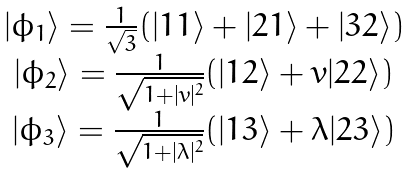Convert formula to latex. <formula><loc_0><loc_0><loc_500><loc_500>\begin{array} { c c c c c c } | \phi _ { 1 } \rangle = \frac { 1 } { \sqrt { 3 } } ( | 1 1 \rangle + | 2 1 \rangle + | 3 2 \rangle ) \\ | \phi _ { 2 } \rangle = \frac { 1 } { \sqrt { 1 + | v | ^ { 2 } } } ( | 1 2 \rangle + v | 2 2 \rangle ) \\ | \phi _ { 3 } \rangle = \frac { 1 } { \sqrt { 1 + | \lambda | ^ { 2 } } } ( | 1 3 \rangle + \lambda | 2 3 \rangle ) \\ \end{array}</formula> 